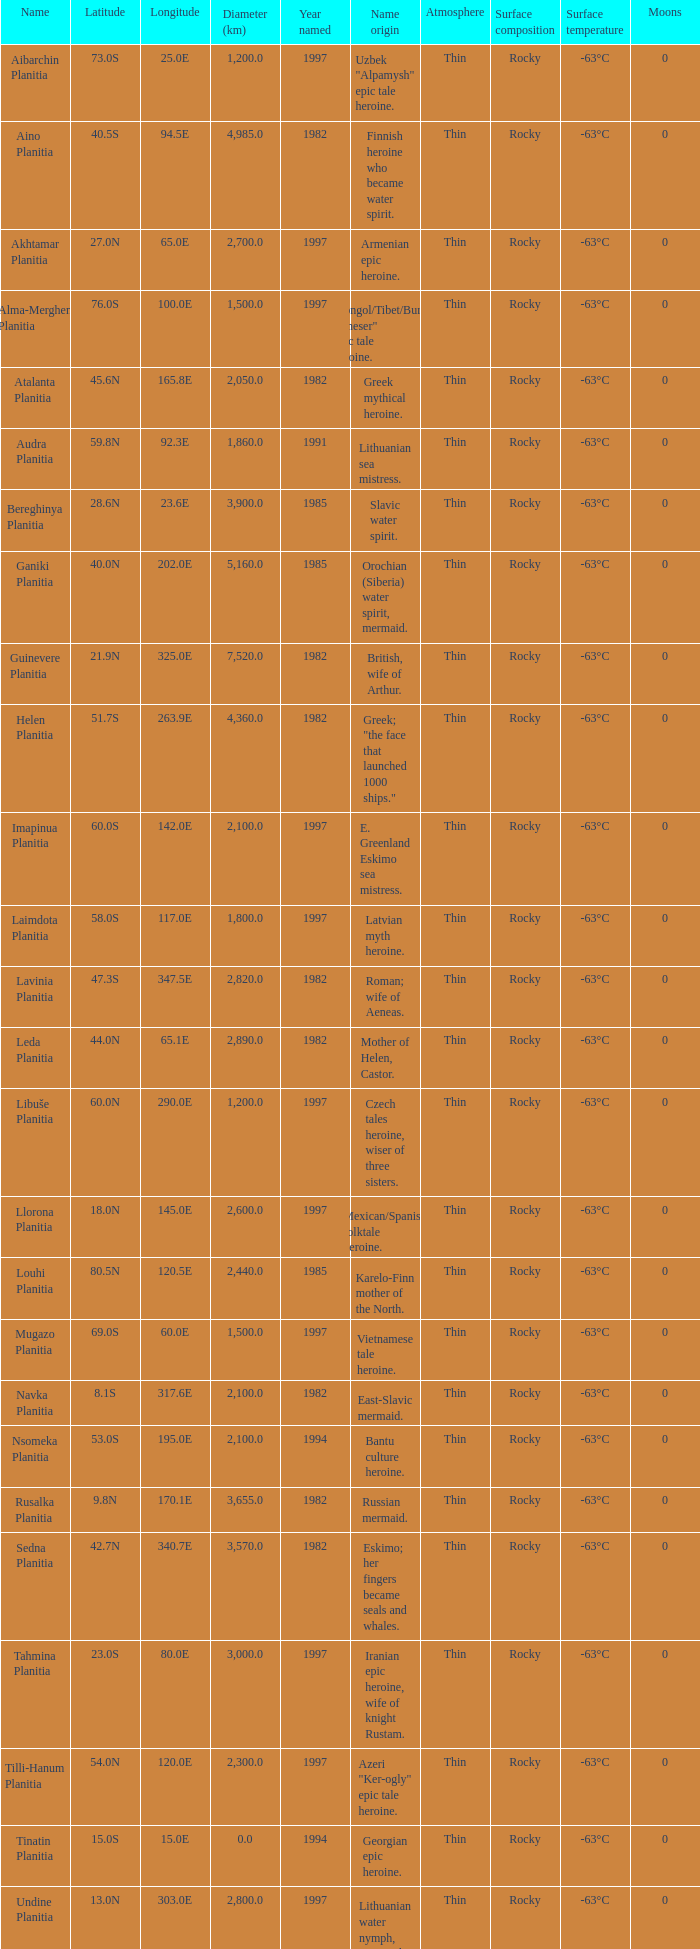What is the latitude of the feature of longitude 80.0e 23.0S. 